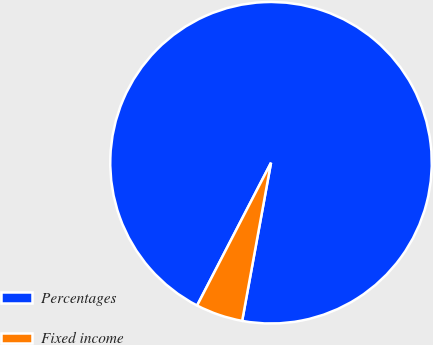Convert chart to OTSL. <chart><loc_0><loc_0><loc_500><loc_500><pie_chart><fcel>Percentages<fcel>Fixed income<nl><fcel>95.27%<fcel>4.73%<nl></chart> 